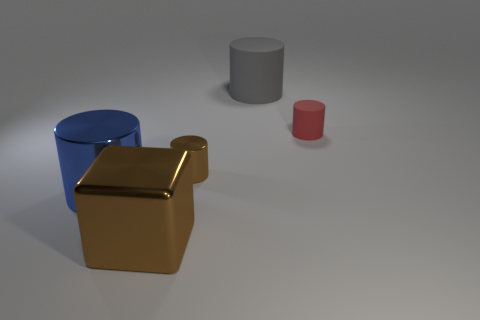Add 5 purple matte balls. How many objects exist? 10 Subtract all cylinders. How many objects are left? 1 Add 3 big cyan matte cubes. How many big cyan matte cubes exist? 3 Subtract 0 brown spheres. How many objects are left? 5 Subtract all small objects. Subtract all big red shiny balls. How many objects are left? 3 Add 5 rubber cylinders. How many rubber cylinders are left? 7 